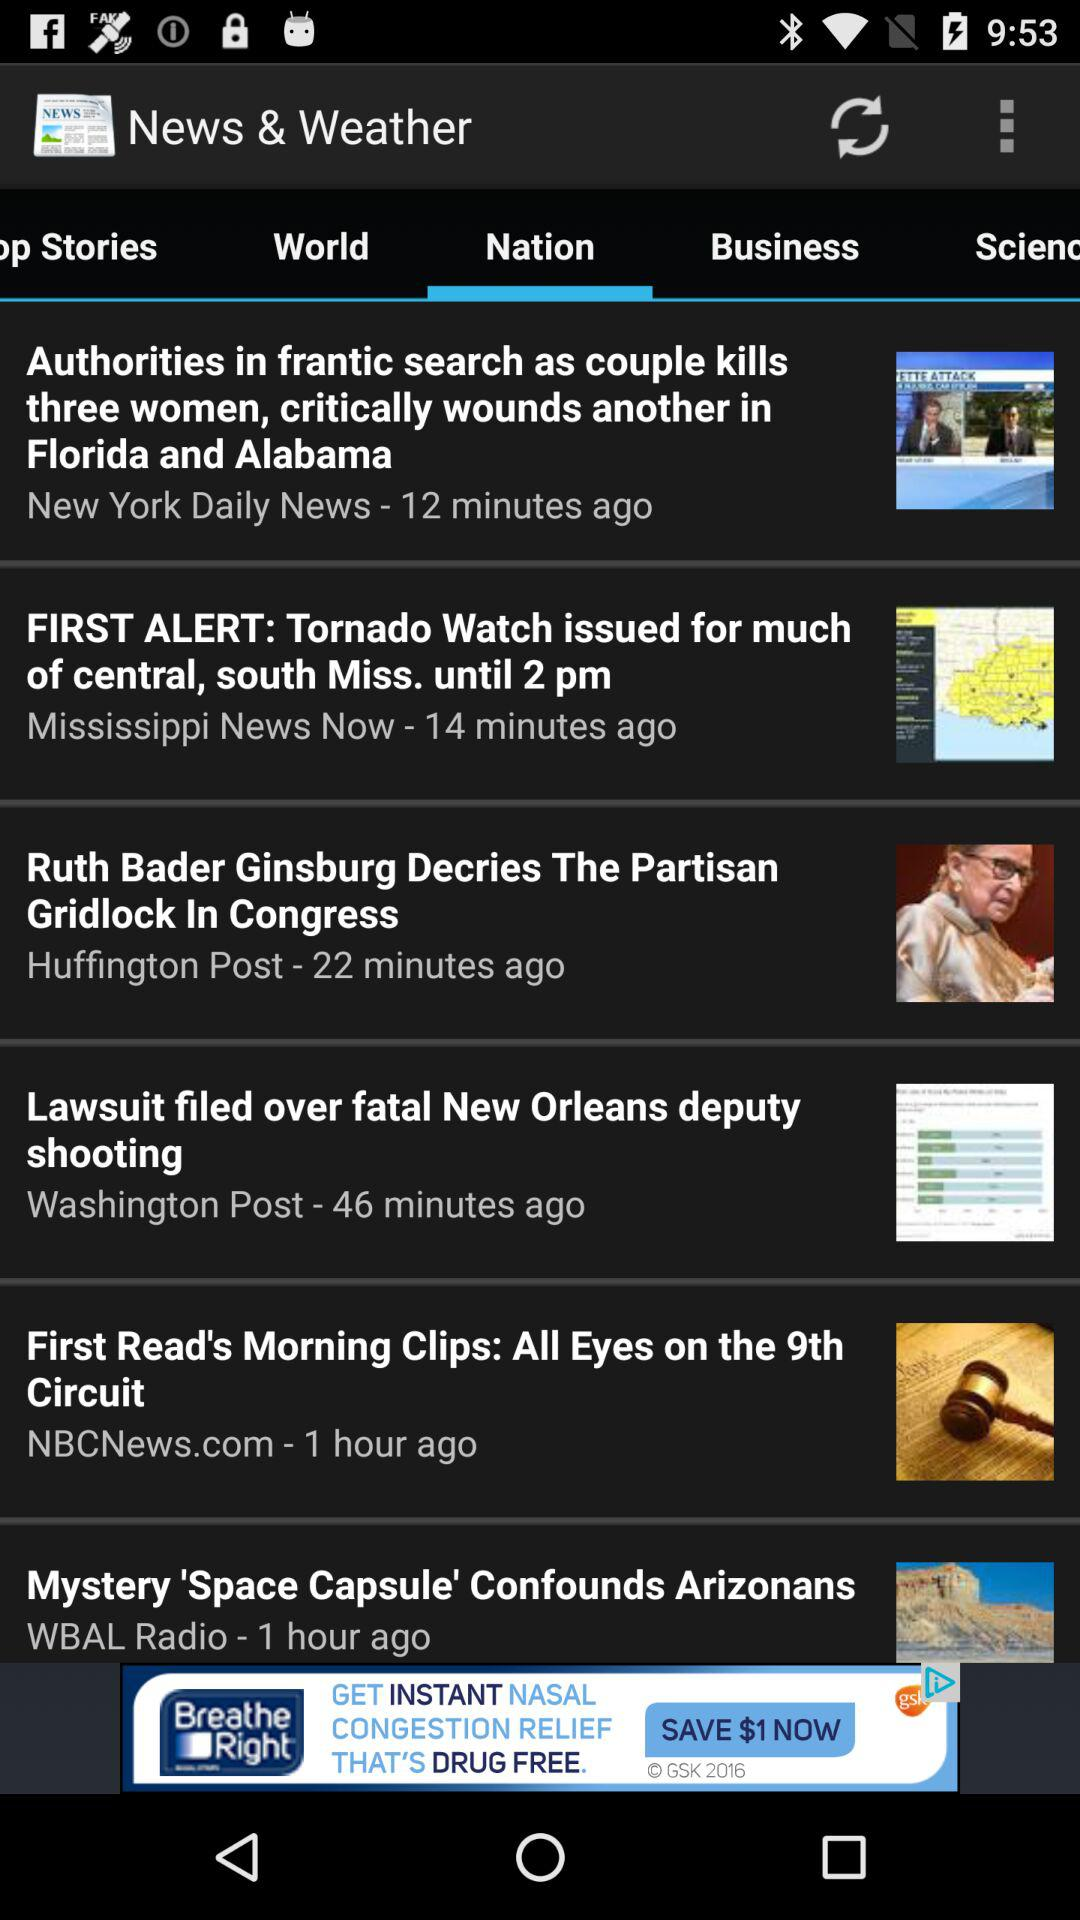How long has it been since "First Read's Morning Clips: All Eyes on the 9th Circuit" was posted? It has been an hour since the news was posted. 